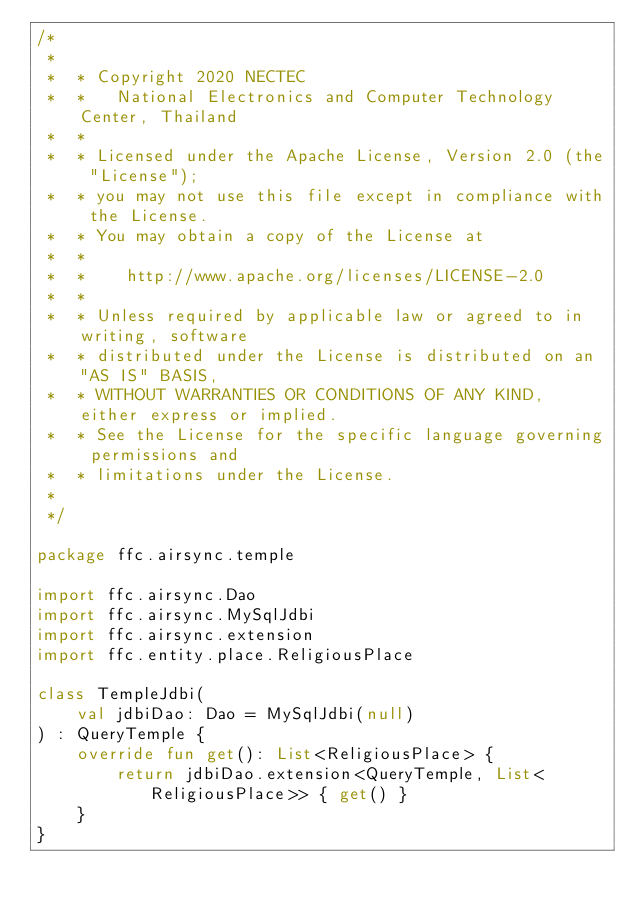<code> <loc_0><loc_0><loc_500><loc_500><_Kotlin_>/*
 *
 *  * Copyright 2020 NECTEC
 *  *   National Electronics and Computer Technology Center, Thailand
 *  *
 *  * Licensed under the Apache License, Version 2.0 (the "License");
 *  * you may not use this file except in compliance with the License.
 *  * You may obtain a copy of the License at
 *  *
 *  *    http://www.apache.org/licenses/LICENSE-2.0
 *  *
 *  * Unless required by applicable law or agreed to in writing, software
 *  * distributed under the License is distributed on an "AS IS" BASIS,
 *  * WITHOUT WARRANTIES OR CONDITIONS OF ANY KIND, either express or implied.
 *  * See the License for the specific language governing permissions and
 *  * limitations under the License.
 *
 */

package ffc.airsync.temple

import ffc.airsync.Dao
import ffc.airsync.MySqlJdbi
import ffc.airsync.extension
import ffc.entity.place.ReligiousPlace

class TempleJdbi(
    val jdbiDao: Dao = MySqlJdbi(null)
) : QueryTemple {
    override fun get(): List<ReligiousPlace> {
        return jdbiDao.extension<QueryTemple, List<ReligiousPlace>> { get() }
    }
}
</code> 